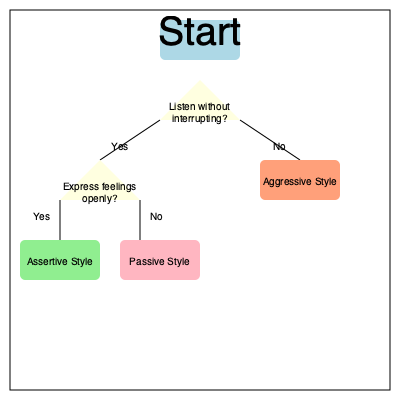Based on the flowchart provided, which communication style is characterized by actively listening without interrupting and openly expressing feelings? To determine the communication style that involves actively listening without interrupting and openly expressing feelings, let's follow the flowchart step-by-step:

1. We start at the top of the flowchart.
2. The first decision point asks, "Listen without interrupting?"
   - We follow the "Yes" branch since the style we're looking for involves active listening.
3. The second decision point asks, "Express feelings openly?"
   - Again, we follow the "Yes" branch since the style involves open expression of feelings.
4. Following these two "Yes" paths leads us to the outcome box labeled "Assertive Style".

Therefore, the communication style that is characterized by actively listening without interrupting and openly expressing feelings is the Assertive Style.

This style is often considered the most effective for healthy communication in relationships, as it balances respect for both oneself and one's partner. It allows for clear expression of thoughts and feelings while also demonstrating attentiveness to the partner's perspective.
Answer: Assertive Style 